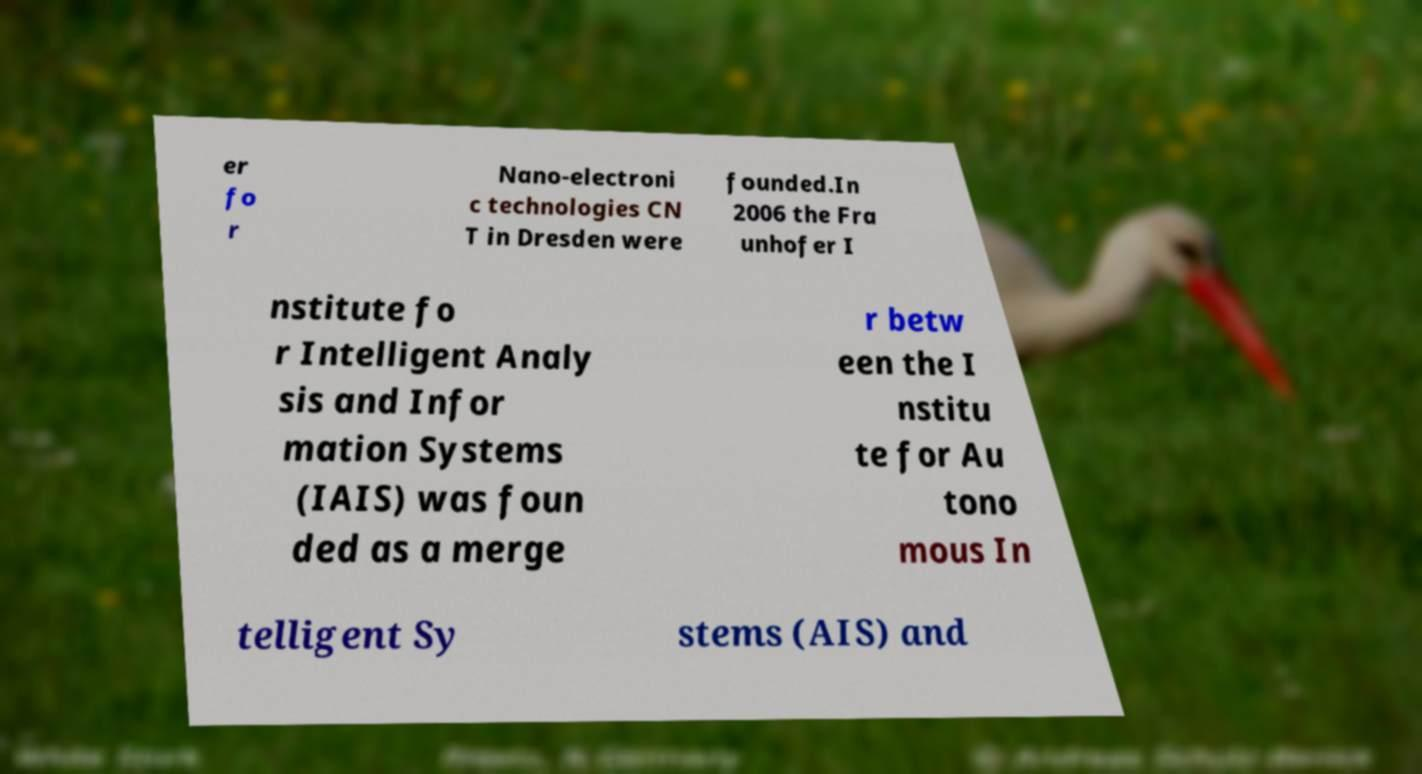There's text embedded in this image that I need extracted. Can you transcribe it verbatim? er fo r Nano-electroni c technologies CN T in Dresden were founded.In 2006 the Fra unhofer I nstitute fo r Intelligent Analy sis and Infor mation Systems (IAIS) was foun ded as a merge r betw een the I nstitu te for Au tono mous In telligent Sy stems (AIS) and 